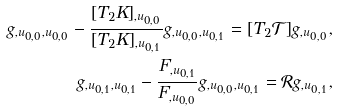Convert formula to latex. <formula><loc_0><loc_0><loc_500><loc_500>g _ { , u _ { 0 , 0 } , u _ { 0 , 0 } } - \frac { [ T _ { 2 } K ] _ { , u _ { 0 , 0 } } } { [ T _ { 2 } K ] _ { , u _ { 0 , 1 } } } g _ { , u _ { 0 , 0 } , u _ { 0 , 1 } } = [ T _ { 2 } \mathcal { T } ] g _ { , u _ { 0 , 0 } } , \\ g _ { , u _ { 0 , 1 } , u _ { 0 , 1 } } - \frac { F _ { , u _ { 0 , 1 } } } { F _ { , u _ { 0 , 0 } } } g _ { , u _ { 0 , 0 } , u _ { 0 , 1 } } = \mathcal { R } g _ { , u _ { 0 , 1 } } ,</formula> 